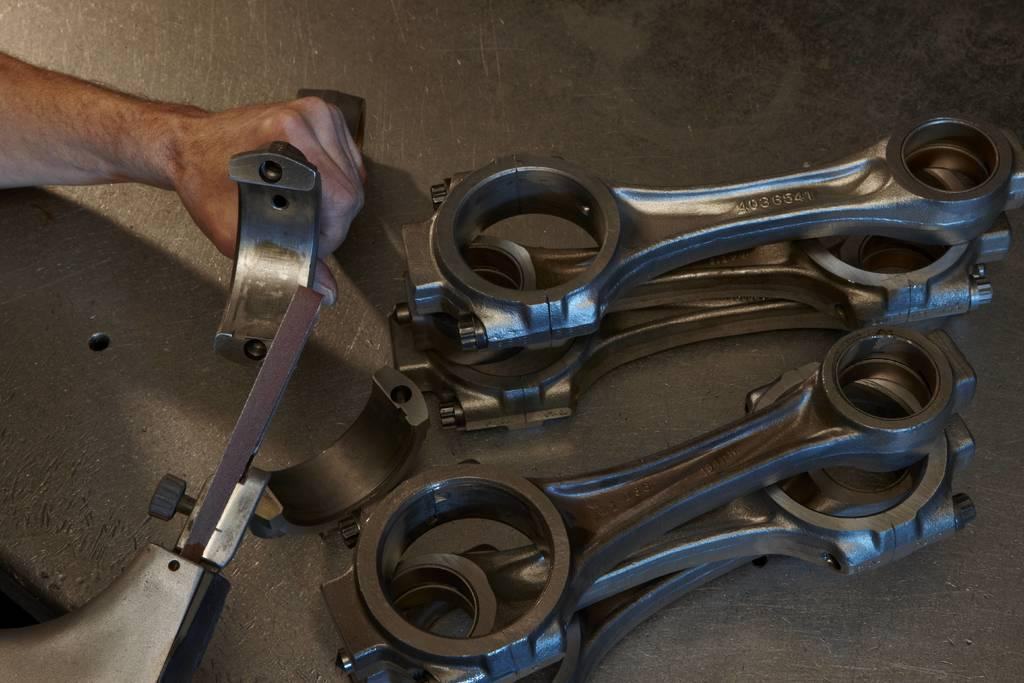What objects are in the foreground of the image? There are wrenches in the foreground of the image. Who or what else is in the foreground of the image? There is a person in the foreground of the image. What is the person holding in the image? The person is holding metal objects. Where are the metal objects located in the image? The metal objects are on a surface. What hobbies does the person in the image enjoy? The provided facts do not mention any hobbies of the person in the image, so we cannot determine their hobbies from the image. 